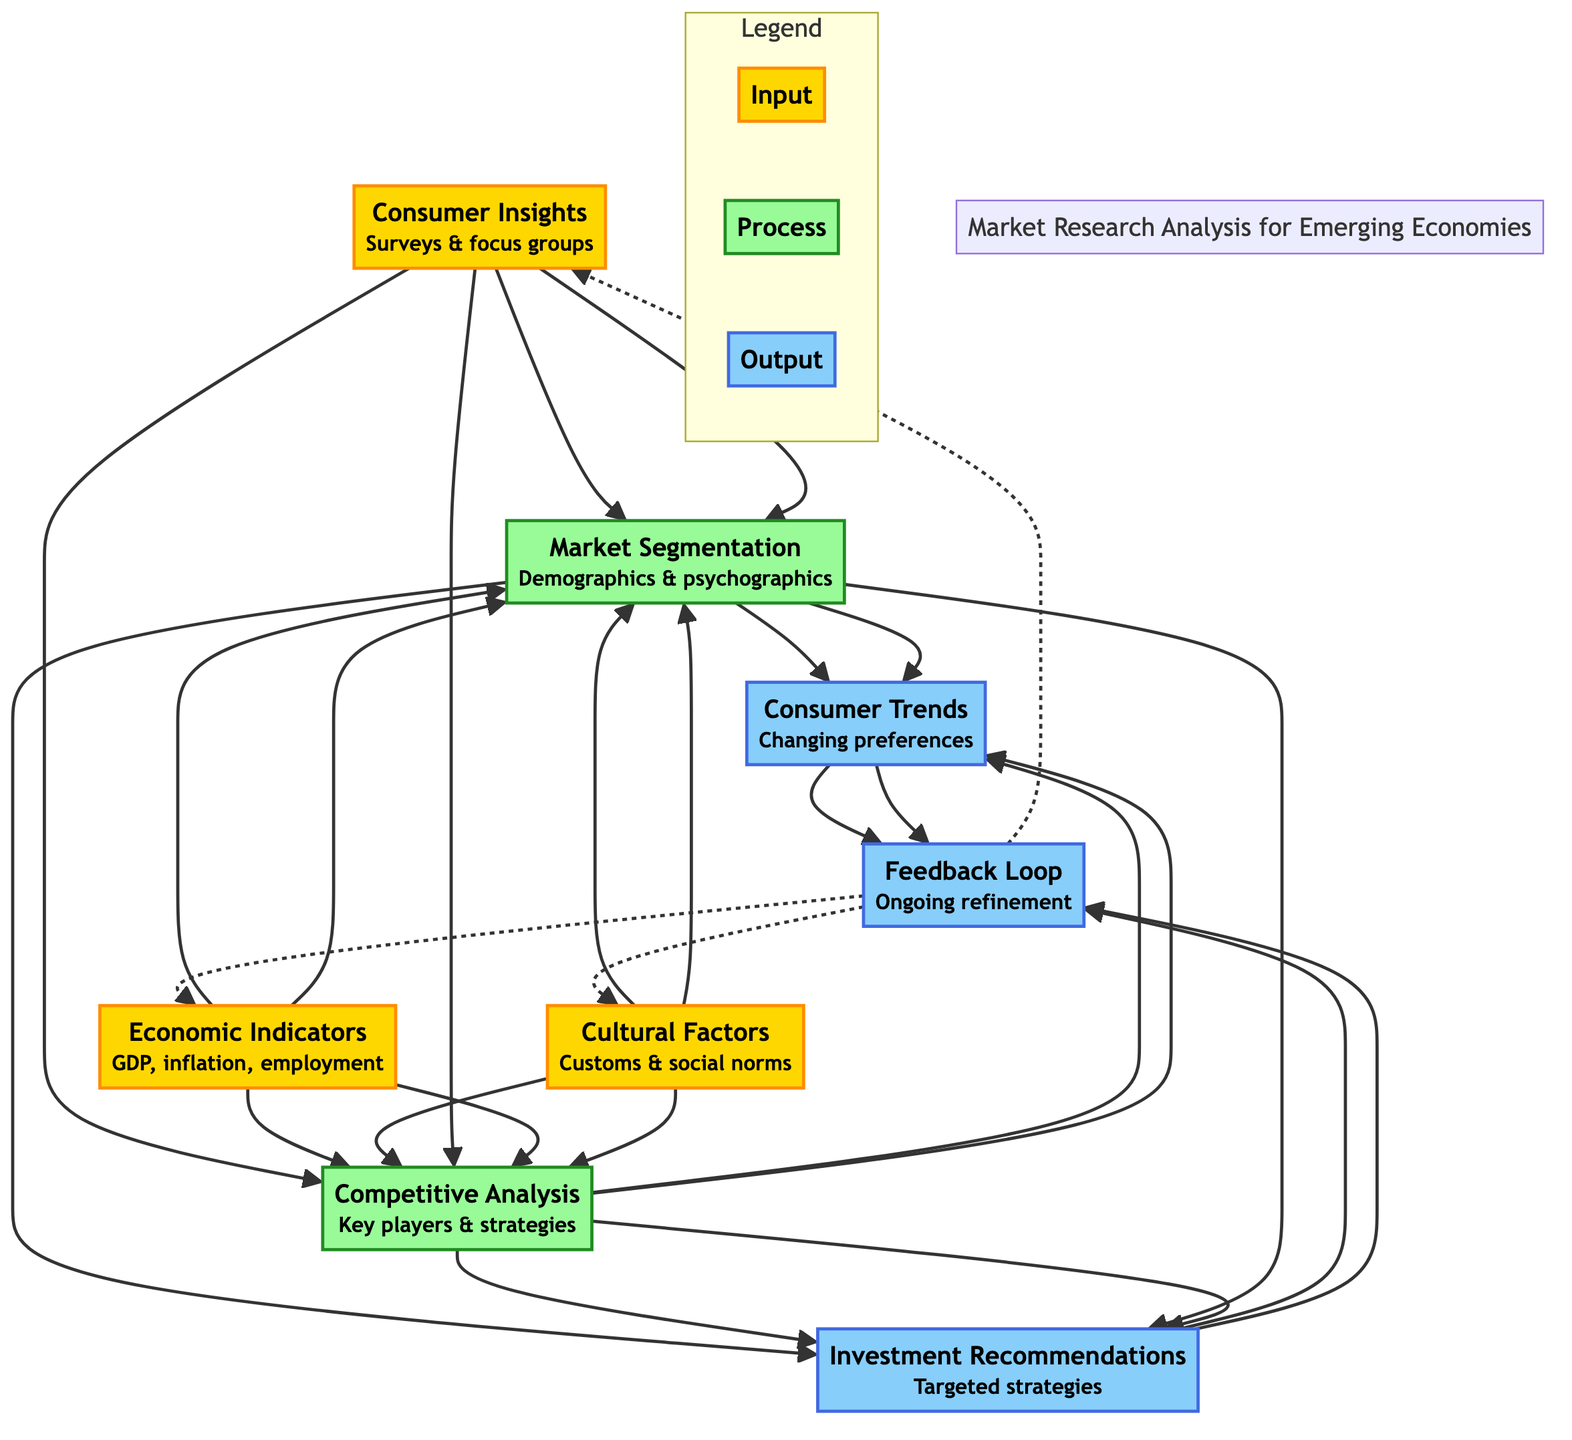What are the three inputs in the diagram? The diagram specifies three inputs identified as "Consumer Insights", "Economic Indicators", and "Cultural Factors." These are directly labeled in the diagram as input nodes.
Answer: Consumer Insights, Economic Indicators, Cultural Factors How many process nodes are there in this flow chart? The diagram contains two process nodes labeled as "Market Segmentation" and "Competitive Analysis." By counting these nodes, we find there are two.
Answer: 2 Which output is generated from both process nodes? The outputs of the diagram include "Consumer Trends" and "Investment Recommendations." Both of these are the result of the inputs being processed by the earlier nodes, showing the collective contribution of both inputs.
Answer: Consumer Trends, Investment Recommendations What inputs lead to the "Market Segmentation" node? The flow chart indicates that the inputs leading to "Market Segmentation" are "Consumer Insights," "Economic Indicators," and "Cultural Factors," as they all point directly to this process.
Answer: Consumer Insights, Economic Indicators, Cultural Factors What happens after the "Feedback Loop" receives information? Once the "Feedback Loop" receives information from the output nodes, it sends feedback back to the input nodes, illustrated by the dashed lines returning to "Consumer Insights", "Economic Indicators", and "Cultural Factors." It indicates a continuous refinement strategy.
Answer: It refines strategies based on input feedback Which output node is derived from examining "Consumer Trends"? The "Feedback Loop" output node is derived from "Consumer Trends." The flow chart shows that after observing Consumer Trends, the next step is to update strategies through the feedback mechanism based on continuous consumer insights.
Answer: Feedback Loop 